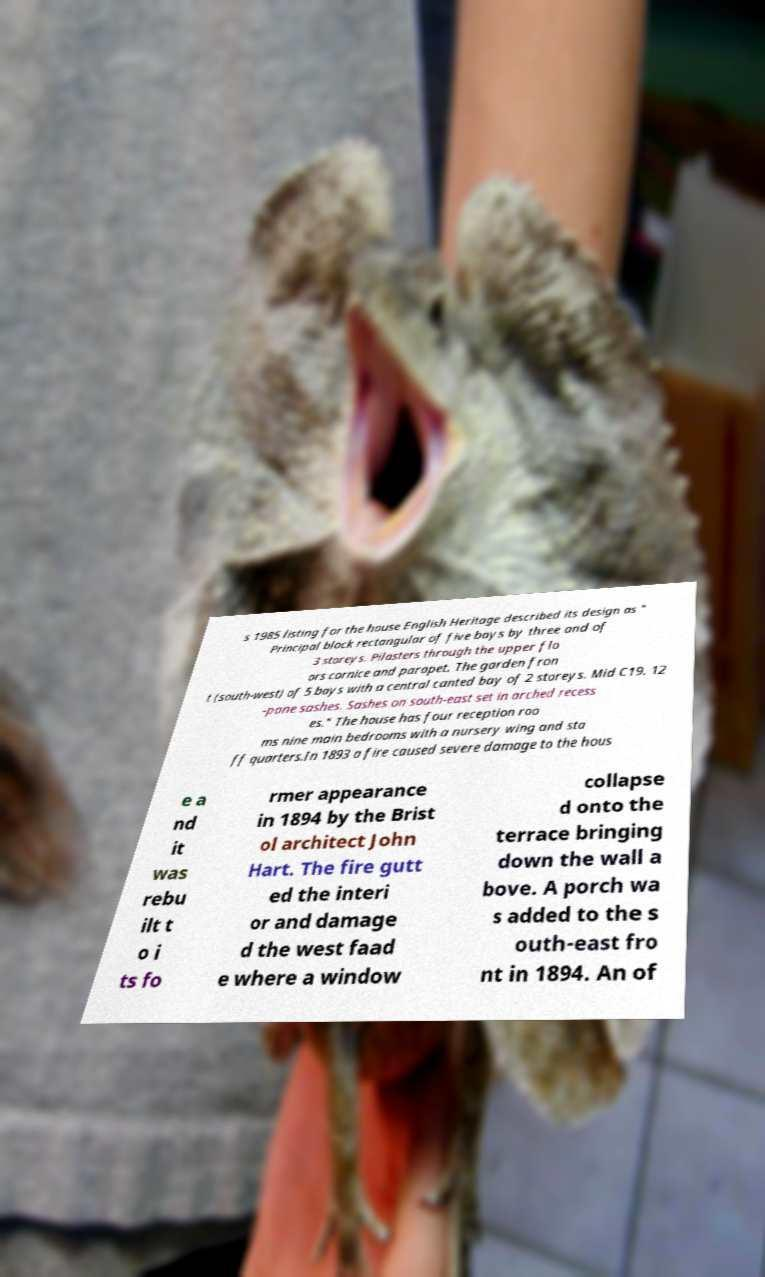I need the written content from this picture converted into text. Can you do that? s 1985 listing for the house English Heritage described its design as " Principal block rectangular of five bays by three and of 3 storeys. Pilasters through the upper flo ors cornice and parapet. The garden fron t (south-west) of 5 bays with a central canted bay of 2 storeys. Mid C19. 12 -pane sashes. Sashes on south-east set in arched recess es." The house has four reception roo ms nine main bedrooms with a nursery wing and sta ff quarters.In 1893 a fire caused severe damage to the hous e a nd it was rebu ilt t o i ts fo rmer appearance in 1894 by the Brist ol architect John Hart. The fire gutt ed the interi or and damage d the west faad e where a window collapse d onto the terrace bringing down the wall a bove. A porch wa s added to the s outh-east fro nt in 1894. An of 